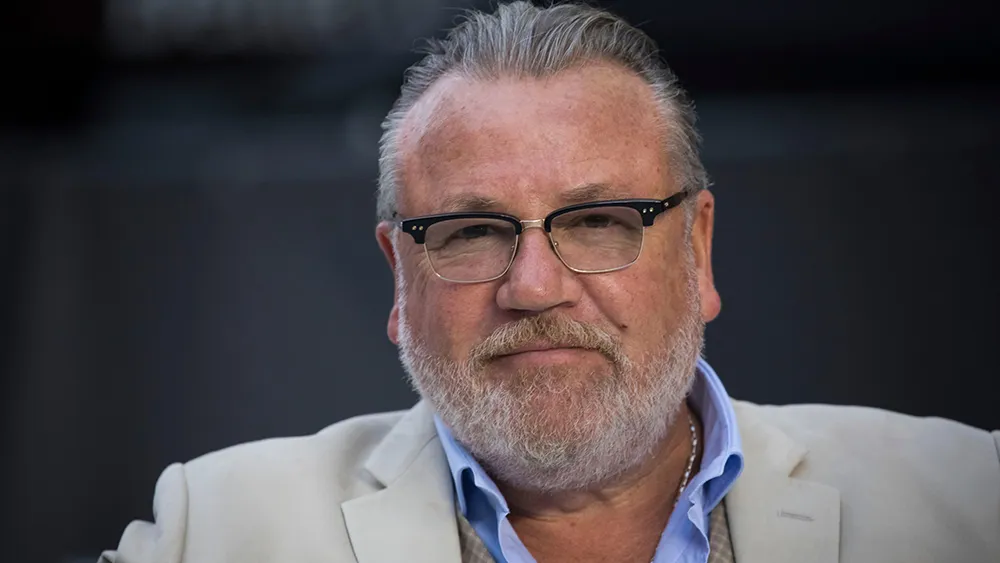Can you elaborate on the elements of the picture provided? The image captures a man with prominent gray facial hair and glasses, wearing a white blazer over a blue shirt. He holds a thoughtful pose, giving the impression of deep contemplation. His attire is neat and adds an element of sophistication. The blurry background suggests a formal setting, directing focus towards him. This setting could be an event or a professional gathering, highlighting his possible prominence or involvement in the event. 